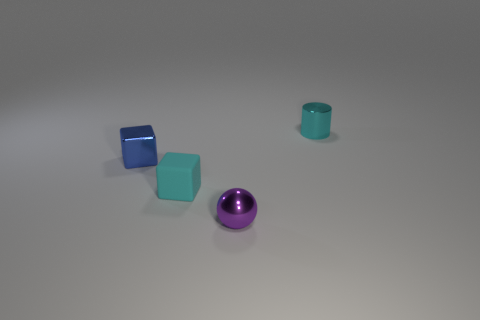Add 4 purple metallic blocks. How many objects exist? 8 Subtract all balls. How many objects are left? 3 Add 2 shiny cylinders. How many shiny cylinders are left? 3 Add 1 small blocks. How many small blocks exist? 3 Subtract 0 brown balls. How many objects are left? 4 Subtract all large yellow metal spheres. Subtract all rubber objects. How many objects are left? 3 